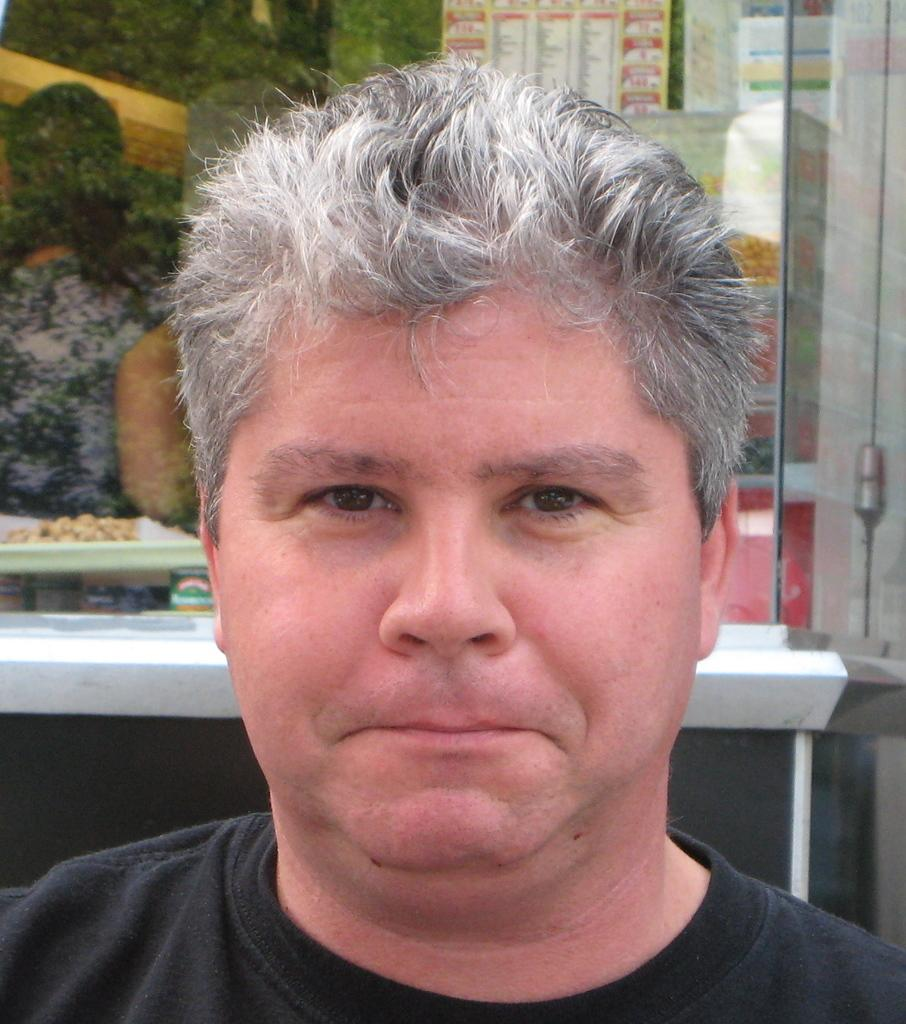Who is present in the image? There is a man in the image. What is the man wearing? The man is wearing a black T-shirt. What can be seen in the background of the image? There is a mirror in the background of the image. What is reflected in the mirror? There is a reflection of a woman in the mirror. What is on the right side of the image? There are posters on the right side of the image. What type of voice can be heard coming from the man in the image? There is no voice present in the image, as it is a still photograph. 